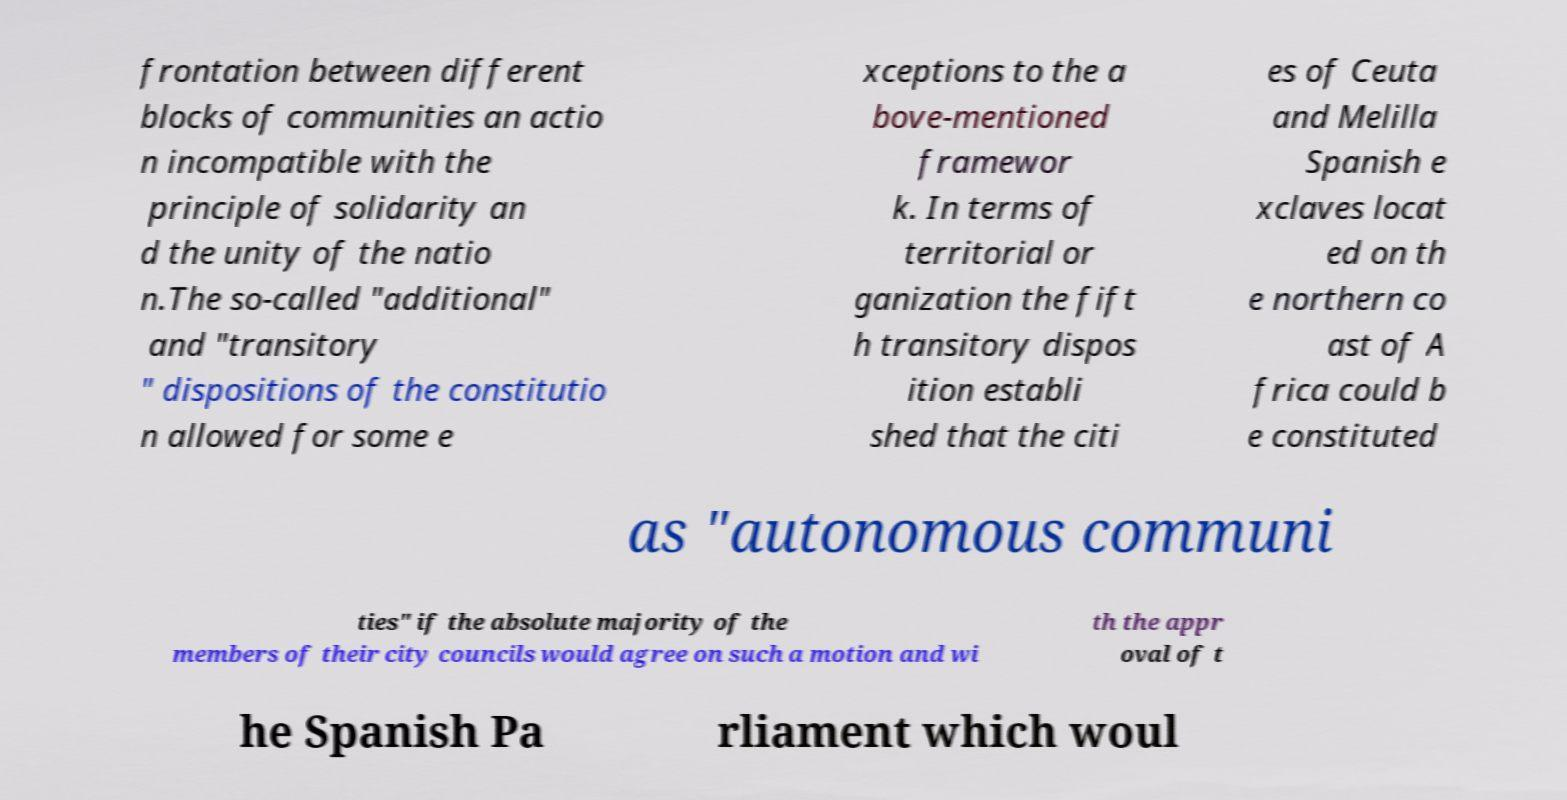I need the written content from this picture converted into text. Can you do that? frontation between different blocks of communities an actio n incompatible with the principle of solidarity an d the unity of the natio n.The so-called "additional" and "transitory " dispositions of the constitutio n allowed for some e xceptions to the a bove-mentioned framewor k. In terms of territorial or ganization the fift h transitory dispos ition establi shed that the citi es of Ceuta and Melilla Spanish e xclaves locat ed on th e northern co ast of A frica could b e constituted as "autonomous communi ties" if the absolute majority of the members of their city councils would agree on such a motion and wi th the appr oval of t he Spanish Pa rliament which woul 